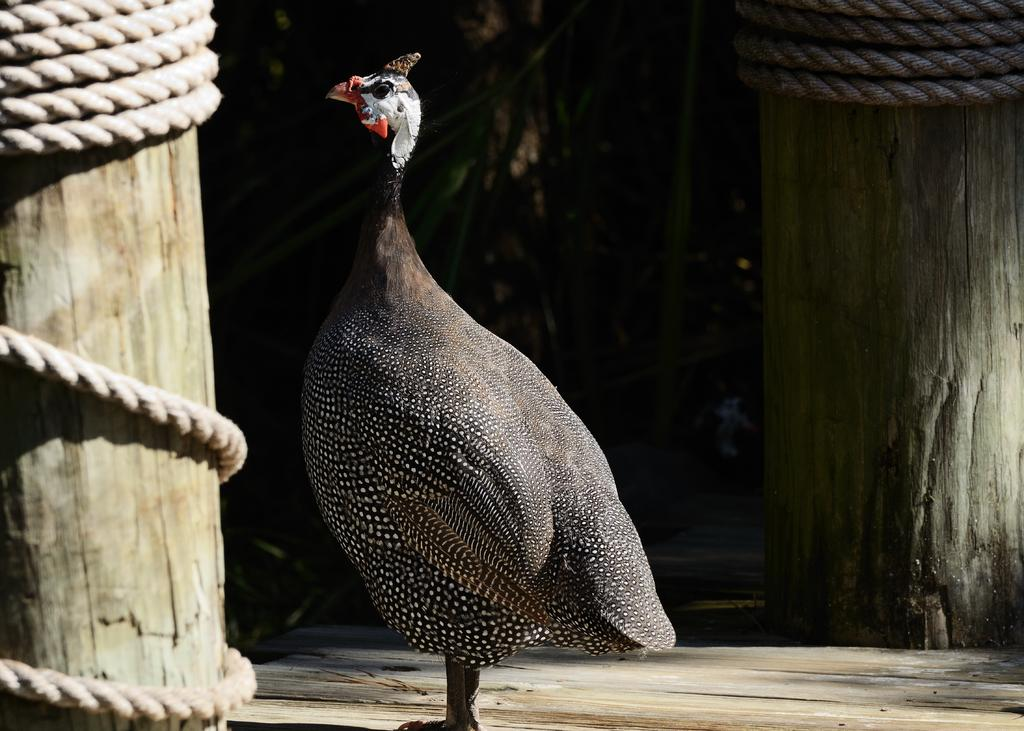What is the main subject in the center of the image? There is a bird in the center of the image. Where is the bird located? The bird is on the ground. What structures can be seen in the image? There are two wooden pillars in the image. What is attached to the wooden pillars? Ropes are present on the wooden pillars. What type of party is happening near the bird in the image? There is no party present in the image; it only features a bird, wooden pillars, and ropes. What is the root system of the tree near the bird in the image? There is no tree present in the image; it only features a bird, wooden pillars, and ropes. 